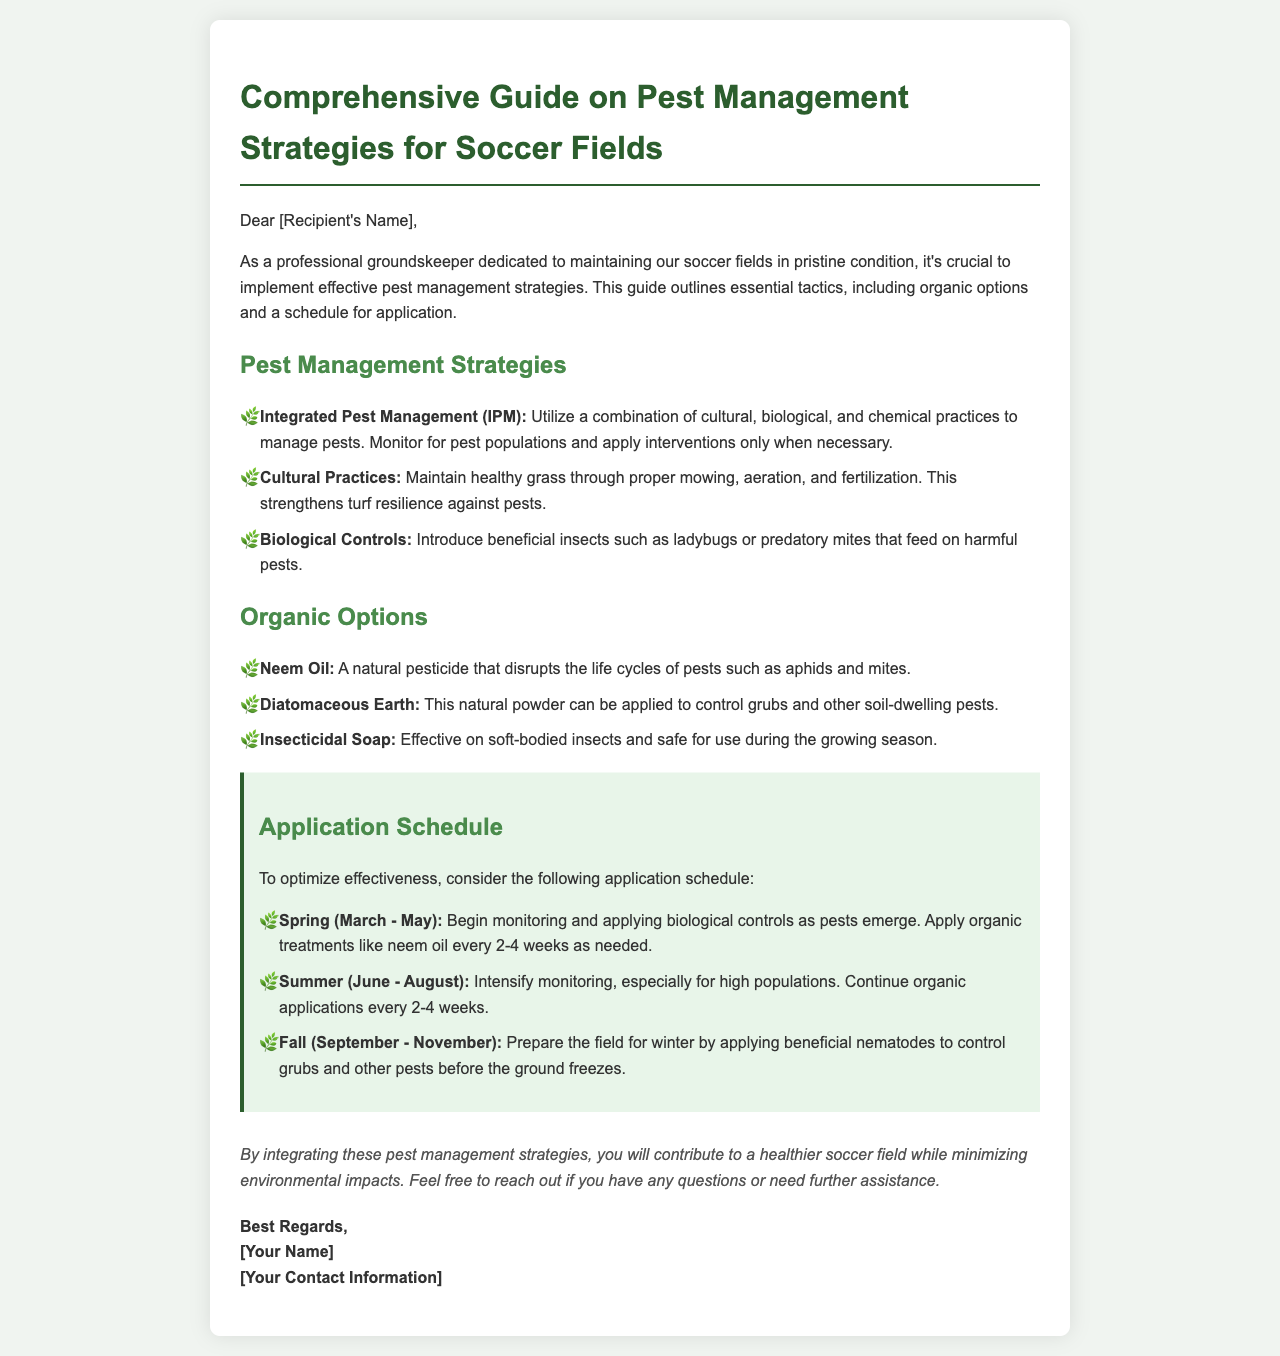What are the three pest management strategies mentioned? The document lists three strategies: Integrated Pest Management (IPM), Cultural Practices, and Biological Controls.
Answer: IPM, Cultural Practices, Biological Controls What organic option is mentioned for controlling aphids? The document specifies Neem Oil as an organic option that disrupts the life cycles of pests such as aphids.
Answer: Neem Oil During which season should beneficial nematodes be applied? The document states that beneficial nematodes should be applied in Fall to control grubs and other pests.
Answer: Fall How often should organic treatments like neem oil be applied in Spring? The document recommends applying organic treatments such as neem oil every 2-4 weeks as needed during Spring.
Answer: Every 2-4 weeks What is the purpose of introducing beneficial insects? The document mentions that beneficial insects are introduced to feed on harmful pests, which helps in pest management.
Answer: Feed on harmful pests What is the primary goal of the pest management strategies outlined? The document emphasizes that the goal is to contribute to a healthier soccer field while minimizing environmental impacts.
Answer: Healthier soccer field Who should the groundskeepers contact for further assistance? The document invites recipients to reach out if they have any questions or need further assistance.
Answer: [Your Name] What decorative element precedes each item in the listed practices? The document uses a leaf emoji (🌿) as a decorative element before each item in the lists.
Answer: Leaf emoji What is the color of the background used in the document? The background color of the document is described to be a light green hue (#f0f4f0).
Answer: Light green 